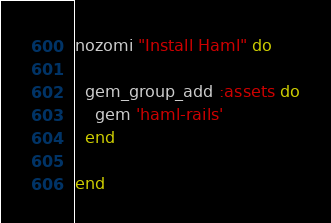Convert code to text. <code><loc_0><loc_0><loc_500><loc_500><_Ruby_>nozomi "Install Haml" do
  
  gem_group_add :assets do
    gem 'haml-rails'
  end
  
end</code> 